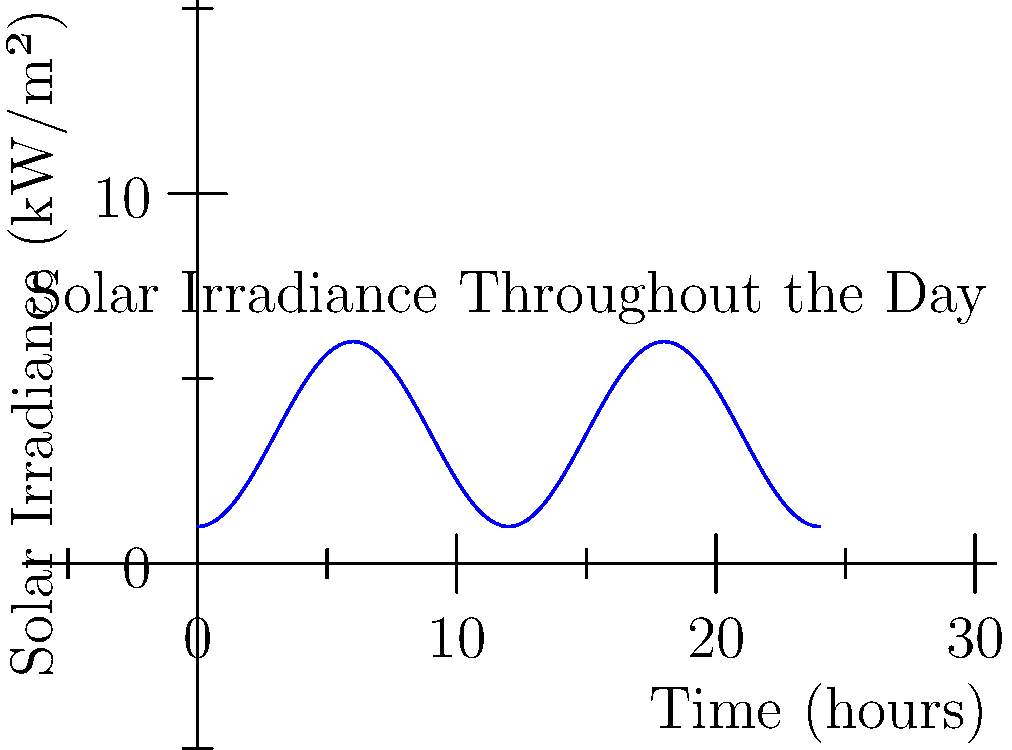Using the graph of solar irradiance throughout the day, calculate the total energy production in kWh/m² for a solar panel with 20% efficiency. Assume the graph represents a typical day and the function for solar irradiance (in kW/m²) is given by $I(t) = 5\sin^2(\frac{\pi t}{12}) + 1$, where $t$ is the time in hours. To solve this problem, we need to follow these steps:

1. Identify the function for solar irradiance:
   $I(t) = 5\sin^2(\frac{\pi t}{12}) + 1$

2. To find the total energy production, we need to integrate this function over the entire day (24 hours):
   $E = \int_0^{24} I(t) dt$

3. Calculate the integral:
   $E = \int_0^{24} (5\sin^2(\frac{\pi t}{12}) + 1) dt$
   $= [5 \cdot \frac{t}{2} - \frac{5}{4\pi}\sin(\frac{\pi t}{6}) + t]_0^{24}$
   $= (60 - 0 + 24) - (0 - 0 + 0) = 84$ kWh/m²

4. Apply the solar panel efficiency:
   $E_{panel} = 84 \cdot 0.20 = 16.8$ kWh/m²

Therefore, the total energy production for a solar panel with 20% efficiency is 16.8 kWh/m².
Answer: 16.8 kWh/m² 